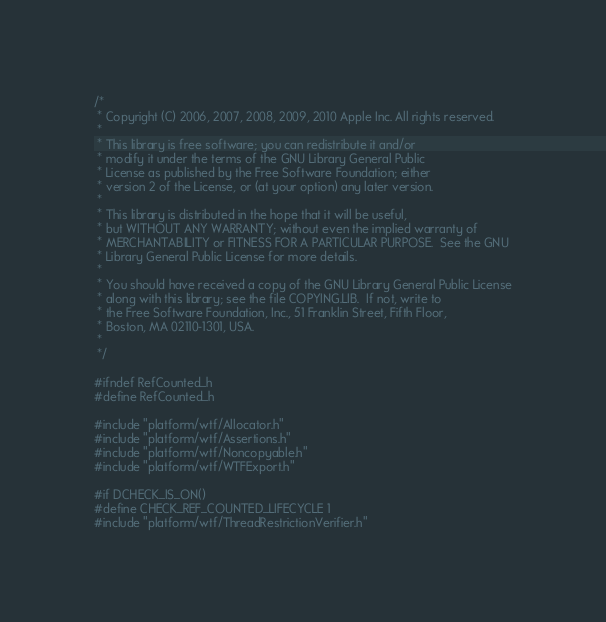<code> <loc_0><loc_0><loc_500><loc_500><_C_>/*
 * Copyright (C) 2006, 2007, 2008, 2009, 2010 Apple Inc. All rights reserved.
 *
 * This library is free software; you can redistribute it and/or
 * modify it under the terms of the GNU Library General Public
 * License as published by the Free Software Foundation; either
 * version 2 of the License, or (at your option) any later version.
 *
 * This library is distributed in the hope that it will be useful,
 * but WITHOUT ANY WARRANTY; without even the implied warranty of
 * MERCHANTABILITY or FITNESS FOR A PARTICULAR PURPOSE.  See the GNU
 * Library General Public License for more details.
 *
 * You should have received a copy of the GNU Library General Public License
 * along with this library; see the file COPYING.LIB.  If not, write to
 * the Free Software Foundation, Inc., 51 Franklin Street, Fifth Floor,
 * Boston, MA 02110-1301, USA.
 *
 */

#ifndef RefCounted_h
#define RefCounted_h

#include "platform/wtf/Allocator.h"
#include "platform/wtf/Assertions.h"
#include "platform/wtf/Noncopyable.h"
#include "platform/wtf/WTFExport.h"

#if DCHECK_IS_ON()
#define CHECK_REF_COUNTED_LIFECYCLE 1
#include "platform/wtf/ThreadRestrictionVerifier.h"</code> 